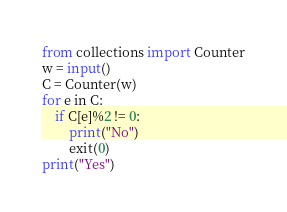<code> <loc_0><loc_0><loc_500><loc_500><_Python_>from collections import Counter
w = input()
C = Counter(w)
for e in C:
    if C[e]%2 != 0:
        print("No")
        exit(0)
print("Yes")
</code> 